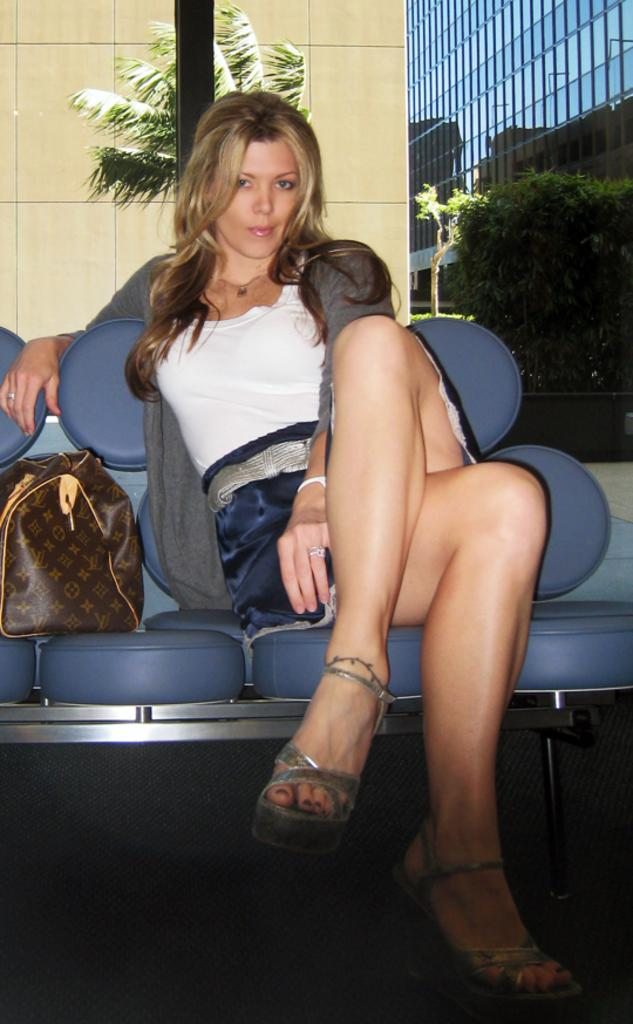Who is the main subject in the image? There is a lady in the image. What is the lady doing in the image? The lady is sitting on a chair. What object is located beside the lady? There is a bag beside the lady. How does the lady start the distribution process in the image? There is no distribution process depicted in the image; the lady is simply sitting on a chair with a bag beside her. 